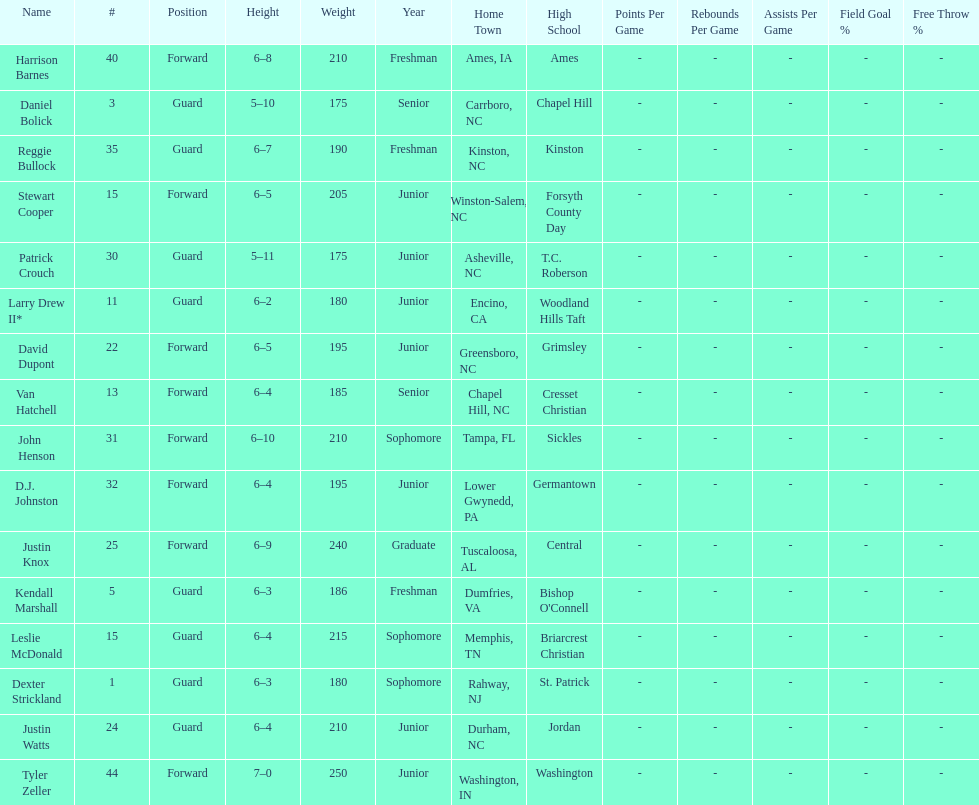Who was taller, justin knox or john henson? John Henson. 